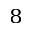Convert formula to latex. <formula><loc_0><loc_0><loc_500><loc_500>_ { 8 }</formula> 